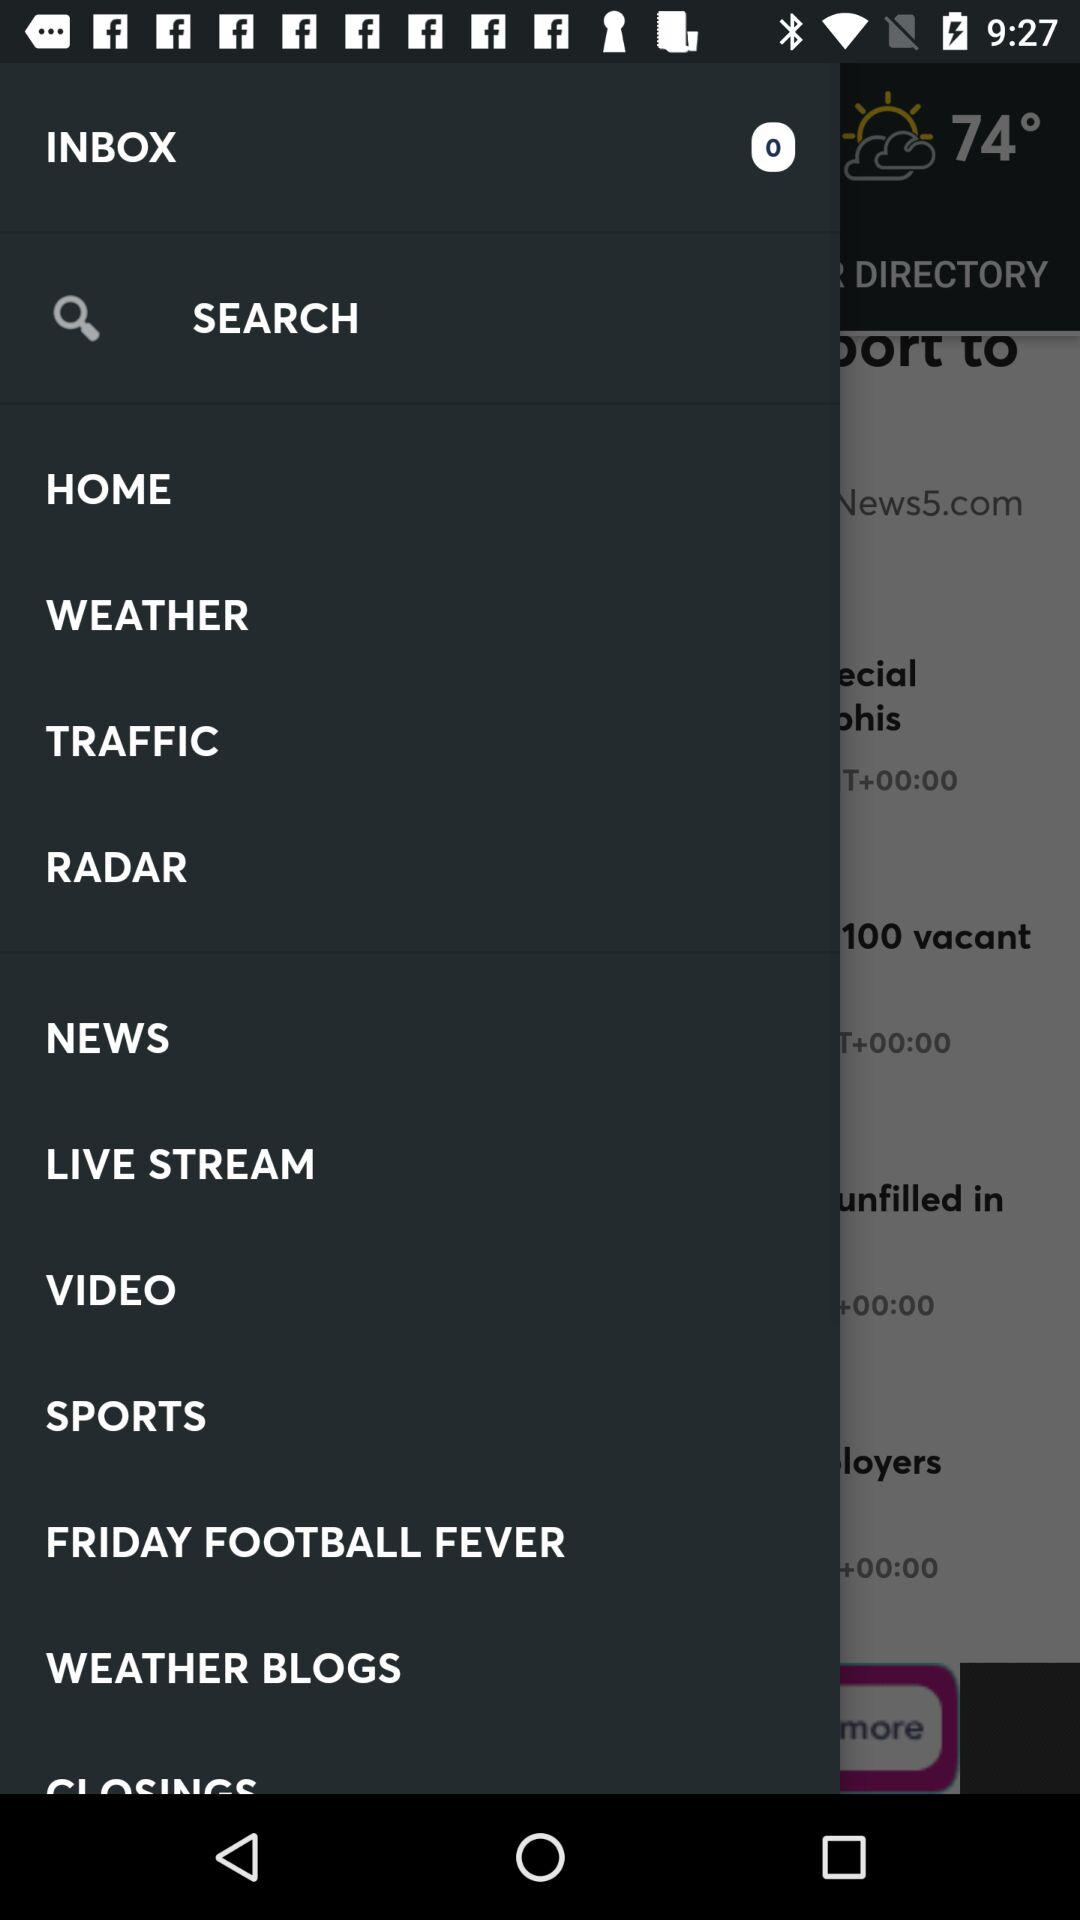What is the temperature shown on the screen? The temperature shown on the screen is 74 degrees. 